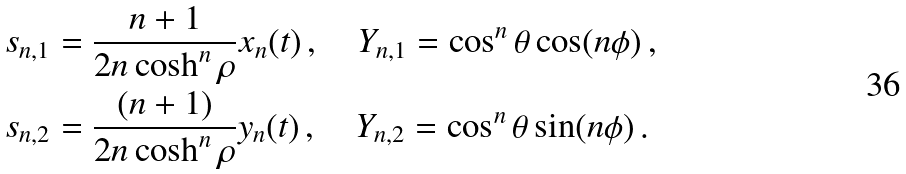Convert formula to latex. <formula><loc_0><loc_0><loc_500><loc_500>s _ { n , 1 } & = \frac { n + 1 } { 2 n \cosh ^ { n } \rho } x _ { n } ( t ) \, , \quad Y _ { n , 1 } = \cos ^ { n } \theta \cos ( n \phi ) \, , \\ s _ { n , 2 } & = \frac { ( n + 1 ) } { 2 n \cosh ^ { n } \rho } y _ { n } ( t ) \, , \quad Y _ { n , 2 } = \cos ^ { n } \theta \sin ( n \phi ) \, .</formula> 